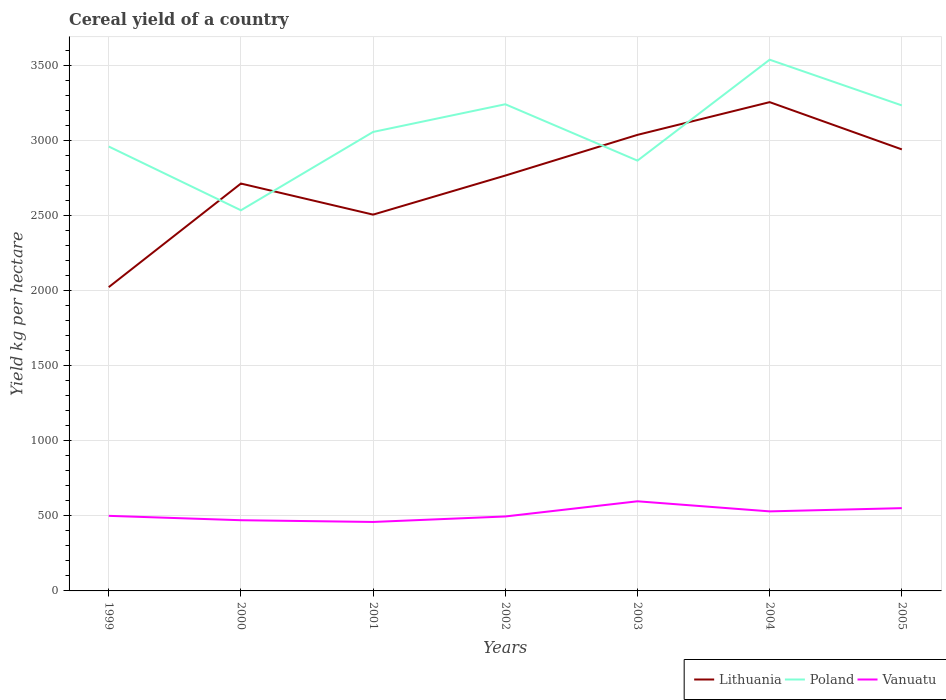How many different coloured lines are there?
Give a very brief answer. 3. Is the number of lines equal to the number of legend labels?
Make the answer very short. Yes. Across all years, what is the maximum total cereal yield in Lithuania?
Keep it short and to the point. 2022.91. What is the total total cereal yield in Vanuatu in the graph?
Make the answer very short. -137.57. What is the difference between the highest and the second highest total cereal yield in Lithuania?
Your response must be concise. 1231.95. How many years are there in the graph?
Keep it short and to the point. 7. What is the difference between two consecutive major ticks on the Y-axis?
Make the answer very short. 500. Where does the legend appear in the graph?
Offer a terse response. Bottom right. How many legend labels are there?
Ensure brevity in your answer.  3. How are the legend labels stacked?
Ensure brevity in your answer.  Horizontal. What is the title of the graph?
Your response must be concise. Cereal yield of a country. What is the label or title of the X-axis?
Your answer should be very brief. Years. What is the label or title of the Y-axis?
Ensure brevity in your answer.  Yield kg per hectare. What is the Yield kg per hectare of Lithuania in 1999?
Provide a succinct answer. 2022.91. What is the Yield kg per hectare of Poland in 1999?
Your answer should be very brief. 2959.36. What is the Yield kg per hectare of Lithuania in 2000?
Ensure brevity in your answer.  2712.78. What is the Yield kg per hectare in Poland in 2000?
Ensure brevity in your answer.  2534.78. What is the Yield kg per hectare of Vanuatu in 2000?
Your answer should be very brief. 470.86. What is the Yield kg per hectare in Lithuania in 2001?
Ensure brevity in your answer.  2505.83. What is the Yield kg per hectare in Poland in 2001?
Your answer should be compact. 3056.4. What is the Yield kg per hectare of Vanuatu in 2001?
Your response must be concise. 459.29. What is the Yield kg per hectare in Lithuania in 2002?
Your response must be concise. 2765.9. What is the Yield kg per hectare of Poland in 2002?
Ensure brevity in your answer.  3240.8. What is the Yield kg per hectare in Vanuatu in 2002?
Provide a succinct answer. 495.79. What is the Yield kg per hectare in Lithuania in 2003?
Offer a terse response. 3037.01. What is the Yield kg per hectare in Poland in 2003?
Offer a very short reply. 2865.37. What is the Yield kg per hectare of Vanuatu in 2003?
Offer a very short reply. 596.86. What is the Yield kg per hectare in Lithuania in 2004?
Your answer should be compact. 3254.87. What is the Yield kg per hectare of Poland in 2004?
Offer a very short reply. 3537.57. What is the Yield kg per hectare of Vanuatu in 2004?
Your response must be concise. 529.69. What is the Yield kg per hectare in Lithuania in 2005?
Your answer should be compact. 2940.17. What is the Yield kg per hectare in Poland in 2005?
Your answer should be compact. 3233.07. What is the Yield kg per hectare in Vanuatu in 2005?
Your response must be concise. 551.28. Across all years, what is the maximum Yield kg per hectare of Lithuania?
Provide a short and direct response. 3254.87. Across all years, what is the maximum Yield kg per hectare of Poland?
Provide a succinct answer. 3537.57. Across all years, what is the maximum Yield kg per hectare in Vanuatu?
Provide a short and direct response. 596.86. Across all years, what is the minimum Yield kg per hectare of Lithuania?
Make the answer very short. 2022.91. Across all years, what is the minimum Yield kg per hectare of Poland?
Your answer should be compact. 2534.78. Across all years, what is the minimum Yield kg per hectare in Vanuatu?
Your answer should be very brief. 459.29. What is the total Yield kg per hectare of Lithuania in the graph?
Give a very brief answer. 1.92e+04. What is the total Yield kg per hectare in Poland in the graph?
Offer a very short reply. 2.14e+04. What is the total Yield kg per hectare of Vanuatu in the graph?
Offer a terse response. 3603.78. What is the difference between the Yield kg per hectare of Lithuania in 1999 and that in 2000?
Your answer should be compact. -689.87. What is the difference between the Yield kg per hectare in Poland in 1999 and that in 2000?
Give a very brief answer. 424.58. What is the difference between the Yield kg per hectare of Vanuatu in 1999 and that in 2000?
Keep it short and to the point. 29.14. What is the difference between the Yield kg per hectare in Lithuania in 1999 and that in 2001?
Your answer should be very brief. -482.92. What is the difference between the Yield kg per hectare of Poland in 1999 and that in 2001?
Give a very brief answer. -97.04. What is the difference between the Yield kg per hectare in Vanuatu in 1999 and that in 2001?
Provide a short and direct response. 40.71. What is the difference between the Yield kg per hectare of Lithuania in 1999 and that in 2002?
Ensure brevity in your answer.  -742.99. What is the difference between the Yield kg per hectare of Poland in 1999 and that in 2002?
Keep it short and to the point. -281.44. What is the difference between the Yield kg per hectare in Vanuatu in 1999 and that in 2002?
Provide a succinct answer. 4.21. What is the difference between the Yield kg per hectare in Lithuania in 1999 and that in 2003?
Your response must be concise. -1014.1. What is the difference between the Yield kg per hectare of Poland in 1999 and that in 2003?
Offer a very short reply. 93.99. What is the difference between the Yield kg per hectare of Vanuatu in 1999 and that in 2003?
Your answer should be very brief. -96.86. What is the difference between the Yield kg per hectare in Lithuania in 1999 and that in 2004?
Provide a succinct answer. -1231.95. What is the difference between the Yield kg per hectare of Poland in 1999 and that in 2004?
Offer a very short reply. -578.2. What is the difference between the Yield kg per hectare in Vanuatu in 1999 and that in 2004?
Provide a short and direct response. -29.69. What is the difference between the Yield kg per hectare of Lithuania in 1999 and that in 2005?
Offer a terse response. -917.26. What is the difference between the Yield kg per hectare of Poland in 1999 and that in 2005?
Keep it short and to the point. -273.71. What is the difference between the Yield kg per hectare of Vanuatu in 1999 and that in 2005?
Your answer should be compact. -51.28. What is the difference between the Yield kg per hectare in Lithuania in 2000 and that in 2001?
Your answer should be compact. 206.96. What is the difference between the Yield kg per hectare of Poland in 2000 and that in 2001?
Make the answer very short. -521.62. What is the difference between the Yield kg per hectare in Vanuatu in 2000 and that in 2001?
Your response must be concise. 11.57. What is the difference between the Yield kg per hectare in Lithuania in 2000 and that in 2002?
Give a very brief answer. -53.12. What is the difference between the Yield kg per hectare in Poland in 2000 and that in 2002?
Your answer should be compact. -706.02. What is the difference between the Yield kg per hectare in Vanuatu in 2000 and that in 2002?
Give a very brief answer. -24.93. What is the difference between the Yield kg per hectare of Lithuania in 2000 and that in 2003?
Keep it short and to the point. -324.23. What is the difference between the Yield kg per hectare in Poland in 2000 and that in 2003?
Offer a very short reply. -330.59. What is the difference between the Yield kg per hectare in Vanuatu in 2000 and that in 2003?
Keep it short and to the point. -126. What is the difference between the Yield kg per hectare in Lithuania in 2000 and that in 2004?
Make the answer very short. -542.08. What is the difference between the Yield kg per hectare of Poland in 2000 and that in 2004?
Provide a succinct answer. -1002.78. What is the difference between the Yield kg per hectare in Vanuatu in 2000 and that in 2004?
Your response must be concise. -58.84. What is the difference between the Yield kg per hectare in Lithuania in 2000 and that in 2005?
Ensure brevity in your answer.  -227.39. What is the difference between the Yield kg per hectare of Poland in 2000 and that in 2005?
Keep it short and to the point. -698.29. What is the difference between the Yield kg per hectare in Vanuatu in 2000 and that in 2005?
Offer a very short reply. -80.42. What is the difference between the Yield kg per hectare in Lithuania in 2001 and that in 2002?
Keep it short and to the point. -260.08. What is the difference between the Yield kg per hectare of Poland in 2001 and that in 2002?
Provide a short and direct response. -184.4. What is the difference between the Yield kg per hectare of Vanuatu in 2001 and that in 2002?
Your answer should be compact. -36.5. What is the difference between the Yield kg per hectare in Lithuania in 2001 and that in 2003?
Your response must be concise. -531.18. What is the difference between the Yield kg per hectare of Poland in 2001 and that in 2003?
Your response must be concise. 191.03. What is the difference between the Yield kg per hectare of Vanuatu in 2001 and that in 2003?
Offer a terse response. -137.57. What is the difference between the Yield kg per hectare in Lithuania in 2001 and that in 2004?
Provide a short and direct response. -749.04. What is the difference between the Yield kg per hectare of Poland in 2001 and that in 2004?
Provide a short and direct response. -481.17. What is the difference between the Yield kg per hectare in Vanuatu in 2001 and that in 2004?
Ensure brevity in your answer.  -70.4. What is the difference between the Yield kg per hectare in Lithuania in 2001 and that in 2005?
Your response must be concise. -434.35. What is the difference between the Yield kg per hectare of Poland in 2001 and that in 2005?
Your answer should be very brief. -176.67. What is the difference between the Yield kg per hectare in Vanuatu in 2001 and that in 2005?
Offer a terse response. -91.99. What is the difference between the Yield kg per hectare in Lithuania in 2002 and that in 2003?
Ensure brevity in your answer.  -271.11. What is the difference between the Yield kg per hectare in Poland in 2002 and that in 2003?
Give a very brief answer. 375.43. What is the difference between the Yield kg per hectare of Vanuatu in 2002 and that in 2003?
Your response must be concise. -101.06. What is the difference between the Yield kg per hectare in Lithuania in 2002 and that in 2004?
Offer a terse response. -488.96. What is the difference between the Yield kg per hectare in Poland in 2002 and that in 2004?
Your answer should be very brief. -296.76. What is the difference between the Yield kg per hectare of Vanuatu in 2002 and that in 2004?
Offer a terse response. -33.9. What is the difference between the Yield kg per hectare in Lithuania in 2002 and that in 2005?
Offer a very short reply. -174.27. What is the difference between the Yield kg per hectare of Poland in 2002 and that in 2005?
Offer a very short reply. 7.73. What is the difference between the Yield kg per hectare of Vanuatu in 2002 and that in 2005?
Provide a short and direct response. -55.49. What is the difference between the Yield kg per hectare in Lithuania in 2003 and that in 2004?
Provide a short and direct response. -217.85. What is the difference between the Yield kg per hectare of Poland in 2003 and that in 2004?
Keep it short and to the point. -672.19. What is the difference between the Yield kg per hectare of Vanuatu in 2003 and that in 2004?
Your answer should be very brief. 67.17. What is the difference between the Yield kg per hectare of Lithuania in 2003 and that in 2005?
Ensure brevity in your answer.  96.84. What is the difference between the Yield kg per hectare of Poland in 2003 and that in 2005?
Ensure brevity in your answer.  -367.7. What is the difference between the Yield kg per hectare of Vanuatu in 2003 and that in 2005?
Your answer should be compact. 45.58. What is the difference between the Yield kg per hectare of Lithuania in 2004 and that in 2005?
Make the answer very short. 314.69. What is the difference between the Yield kg per hectare in Poland in 2004 and that in 2005?
Your answer should be compact. 304.5. What is the difference between the Yield kg per hectare of Vanuatu in 2004 and that in 2005?
Provide a short and direct response. -21.59. What is the difference between the Yield kg per hectare of Lithuania in 1999 and the Yield kg per hectare of Poland in 2000?
Offer a very short reply. -511.87. What is the difference between the Yield kg per hectare in Lithuania in 1999 and the Yield kg per hectare in Vanuatu in 2000?
Make the answer very short. 1552.05. What is the difference between the Yield kg per hectare in Poland in 1999 and the Yield kg per hectare in Vanuatu in 2000?
Ensure brevity in your answer.  2488.5. What is the difference between the Yield kg per hectare of Lithuania in 1999 and the Yield kg per hectare of Poland in 2001?
Your answer should be very brief. -1033.49. What is the difference between the Yield kg per hectare in Lithuania in 1999 and the Yield kg per hectare in Vanuatu in 2001?
Ensure brevity in your answer.  1563.62. What is the difference between the Yield kg per hectare of Poland in 1999 and the Yield kg per hectare of Vanuatu in 2001?
Offer a terse response. 2500.07. What is the difference between the Yield kg per hectare of Lithuania in 1999 and the Yield kg per hectare of Poland in 2002?
Offer a terse response. -1217.89. What is the difference between the Yield kg per hectare of Lithuania in 1999 and the Yield kg per hectare of Vanuatu in 2002?
Provide a succinct answer. 1527.12. What is the difference between the Yield kg per hectare of Poland in 1999 and the Yield kg per hectare of Vanuatu in 2002?
Your response must be concise. 2463.57. What is the difference between the Yield kg per hectare of Lithuania in 1999 and the Yield kg per hectare of Poland in 2003?
Make the answer very short. -842.46. What is the difference between the Yield kg per hectare of Lithuania in 1999 and the Yield kg per hectare of Vanuatu in 2003?
Your answer should be compact. 1426.05. What is the difference between the Yield kg per hectare of Poland in 1999 and the Yield kg per hectare of Vanuatu in 2003?
Provide a short and direct response. 2362.5. What is the difference between the Yield kg per hectare in Lithuania in 1999 and the Yield kg per hectare in Poland in 2004?
Provide a succinct answer. -1514.65. What is the difference between the Yield kg per hectare of Lithuania in 1999 and the Yield kg per hectare of Vanuatu in 2004?
Your answer should be compact. 1493.22. What is the difference between the Yield kg per hectare of Poland in 1999 and the Yield kg per hectare of Vanuatu in 2004?
Your answer should be compact. 2429.67. What is the difference between the Yield kg per hectare in Lithuania in 1999 and the Yield kg per hectare in Poland in 2005?
Offer a terse response. -1210.16. What is the difference between the Yield kg per hectare of Lithuania in 1999 and the Yield kg per hectare of Vanuatu in 2005?
Keep it short and to the point. 1471.63. What is the difference between the Yield kg per hectare of Poland in 1999 and the Yield kg per hectare of Vanuatu in 2005?
Provide a succinct answer. 2408.08. What is the difference between the Yield kg per hectare in Lithuania in 2000 and the Yield kg per hectare in Poland in 2001?
Your answer should be compact. -343.62. What is the difference between the Yield kg per hectare in Lithuania in 2000 and the Yield kg per hectare in Vanuatu in 2001?
Ensure brevity in your answer.  2253.49. What is the difference between the Yield kg per hectare of Poland in 2000 and the Yield kg per hectare of Vanuatu in 2001?
Your answer should be compact. 2075.49. What is the difference between the Yield kg per hectare in Lithuania in 2000 and the Yield kg per hectare in Poland in 2002?
Your answer should be compact. -528.02. What is the difference between the Yield kg per hectare of Lithuania in 2000 and the Yield kg per hectare of Vanuatu in 2002?
Offer a very short reply. 2216.99. What is the difference between the Yield kg per hectare of Poland in 2000 and the Yield kg per hectare of Vanuatu in 2002?
Offer a terse response. 2038.99. What is the difference between the Yield kg per hectare of Lithuania in 2000 and the Yield kg per hectare of Poland in 2003?
Provide a short and direct response. -152.59. What is the difference between the Yield kg per hectare of Lithuania in 2000 and the Yield kg per hectare of Vanuatu in 2003?
Make the answer very short. 2115.92. What is the difference between the Yield kg per hectare of Poland in 2000 and the Yield kg per hectare of Vanuatu in 2003?
Make the answer very short. 1937.92. What is the difference between the Yield kg per hectare of Lithuania in 2000 and the Yield kg per hectare of Poland in 2004?
Your answer should be compact. -824.78. What is the difference between the Yield kg per hectare in Lithuania in 2000 and the Yield kg per hectare in Vanuatu in 2004?
Keep it short and to the point. 2183.09. What is the difference between the Yield kg per hectare in Poland in 2000 and the Yield kg per hectare in Vanuatu in 2004?
Your response must be concise. 2005.09. What is the difference between the Yield kg per hectare of Lithuania in 2000 and the Yield kg per hectare of Poland in 2005?
Your response must be concise. -520.29. What is the difference between the Yield kg per hectare of Lithuania in 2000 and the Yield kg per hectare of Vanuatu in 2005?
Provide a succinct answer. 2161.5. What is the difference between the Yield kg per hectare in Poland in 2000 and the Yield kg per hectare in Vanuatu in 2005?
Provide a succinct answer. 1983.5. What is the difference between the Yield kg per hectare in Lithuania in 2001 and the Yield kg per hectare in Poland in 2002?
Offer a terse response. -734.98. What is the difference between the Yield kg per hectare of Lithuania in 2001 and the Yield kg per hectare of Vanuatu in 2002?
Give a very brief answer. 2010.03. What is the difference between the Yield kg per hectare of Poland in 2001 and the Yield kg per hectare of Vanuatu in 2002?
Keep it short and to the point. 2560.61. What is the difference between the Yield kg per hectare of Lithuania in 2001 and the Yield kg per hectare of Poland in 2003?
Offer a very short reply. -359.55. What is the difference between the Yield kg per hectare in Lithuania in 2001 and the Yield kg per hectare in Vanuatu in 2003?
Offer a very short reply. 1908.97. What is the difference between the Yield kg per hectare in Poland in 2001 and the Yield kg per hectare in Vanuatu in 2003?
Offer a terse response. 2459.54. What is the difference between the Yield kg per hectare of Lithuania in 2001 and the Yield kg per hectare of Poland in 2004?
Your response must be concise. -1031.74. What is the difference between the Yield kg per hectare of Lithuania in 2001 and the Yield kg per hectare of Vanuatu in 2004?
Offer a terse response. 1976.13. What is the difference between the Yield kg per hectare of Poland in 2001 and the Yield kg per hectare of Vanuatu in 2004?
Give a very brief answer. 2526.7. What is the difference between the Yield kg per hectare in Lithuania in 2001 and the Yield kg per hectare in Poland in 2005?
Your answer should be compact. -727.24. What is the difference between the Yield kg per hectare of Lithuania in 2001 and the Yield kg per hectare of Vanuatu in 2005?
Your answer should be very brief. 1954.54. What is the difference between the Yield kg per hectare in Poland in 2001 and the Yield kg per hectare in Vanuatu in 2005?
Ensure brevity in your answer.  2505.12. What is the difference between the Yield kg per hectare of Lithuania in 2002 and the Yield kg per hectare of Poland in 2003?
Make the answer very short. -99.47. What is the difference between the Yield kg per hectare of Lithuania in 2002 and the Yield kg per hectare of Vanuatu in 2003?
Keep it short and to the point. 2169.05. What is the difference between the Yield kg per hectare in Poland in 2002 and the Yield kg per hectare in Vanuatu in 2003?
Provide a short and direct response. 2643.94. What is the difference between the Yield kg per hectare of Lithuania in 2002 and the Yield kg per hectare of Poland in 2004?
Your answer should be very brief. -771.66. What is the difference between the Yield kg per hectare in Lithuania in 2002 and the Yield kg per hectare in Vanuatu in 2004?
Make the answer very short. 2236.21. What is the difference between the Yield kg per hectare of Poland in 2002 and the Yield kg per hectare of Vanuatu in 2004?
Keep it short and to the point. 2711.11. What is the difference between the Yield kg per hectare of Lithuania in 2002 and the Yield kg per hectare of Poland in 2005?
Provide a succinct answer. -467.17. What is the difference between the Yield kg per hectare of Lithuania in 2002 and the Yield kg per hectare of Vanuatu in 2005?
Your answer should be compact. 2214.62. What is the difference between the Yield kg per hectare of Poland in 2002 and the Yield kg per hectare of Vanuatu in 2005?
Your answer should be compact. 2689.52. What is the difference between the Yield kg per hectare in Lithuania in 2003 and the Yield kg per hectare in Poland in 2004?
Give a very brief answer. -500.55. What is the difference between the Yield kg per hectare in Lithuania in 2003 and the Yield kg per hectare in Vanuatu in 2004?
Keep it short and to the point. 2507.32. What is the difference between the Yield kg per hectare of Poland in 2003 and the Yield kg per hectare of Vanuatu in 2004?
Offer a very short reply. 2335.68. What is the difference between the Yield kg per hectare of Lithuania in 2003 and the Yield kg per hectare of Poland in 2005?
Make the answer very short. -196.06. What is the difference between the Yield kg per hectare in Lithuania in 2003 and the Yield kg per hectare in Vanuatu in 2005?
Offer a very short reply. 2485.73. What is the difference between the Yield kg per hectare in Poland in 2003 and the Yield kg per hectare in Vanuatu in 2005?
Your answer should be very brief. 2314.09. What is the difference between the Yield kg per hectare in Lithuania in 2004 and the Yield kg per hectare in Poland in 2005?
Keep it short and to the point. 21.8. What is the difference between the Yield kg per hectare in Lithuania in 2004 and the Yield kg per hectare in Vanuatu in 2005?
Provide a short and direct response. 2703.58. What is the difference between the Yield kg per hectare of Poland in 2004 and the Yield kg per hectare of Vanuatu in 2005?
Your response must be concise. 2986.28. What is the average Yield kg per hectare of Lithuania per year?
Provide a short and direct response. 2748.5. What is the average Yield kg per hectare of Poland per year?
Ensure brevity in your answer.  3061.05. What is the average Yield kg per hectare in Vanuatu per year?
Offer a terse response. 514.83. In the year 1999, what is the difference between the Yield kg per hectare in Lithuania and Yield kg per hectare in Poland?
Provide a short and direct response. -936.45. In the year 1999, what is the difference between the Yield kg per hectare in Lithuania and Yield kg per hectare in Vanuatu?
Provide a short and direct response. 1522.91. In the year 1999, what is the difference between the Yield kg per hectare of Poland and Yield kg per hectare of Vanuatu?
Offer a very short reply. 2459.36. In the year 2000, what is the difference between the Yield kg per hectare in Lithuania and Yield kg per hectare in Poland?
Offer a very short reply. 178. In the year 2000, what is the difference between the Yield kg per hectare of Lithuania and Yield kg per hectare of Vanuatu?
Offer a very short reply. 2241.92. In the year 2000, what is the difference between the Yield kg per hectare in Poland and Yield kg per hectare in Vanuatu?
Offer a terse response. 2063.92. In the year 2001, what is the difference between the Yield kg per hectare of Lithuania and Yield kg per hectare of Poland?
Provide a short and direct response. -550.57. In the year 2001, what is the difference between the Yield kg per hectare of Lithuania and Yield kg per hectare of Vanuatu?
Keep it short and to the point. 2046.53. In the year 2001, what is the difference between the Yield kg per hectare of Poland and Yield kg per hectare of Vanuatu?
Give a very brief answer. 2597.11. In the year 2002, what is the difference between the Yield kg per hectare of Lithuania and Yield kg per hectare of Poland?
Your answer should be compact. -474.9. In the year 2002, what is the difference between the Yield kg per hectare of Lithuania and Yield kg per hectare of Vanuatu?
Provide a short and direct response. 2270.11. In the year 2002, what is the difference between the Yield kg per hectare in Poland and Yield kg per hectare in Vanuatu?
Your response must be concise. 2745.01. In the year 2003, what is the difference between the Yield kg per hectare of Lithuania and Yield kg per hectare of Poland?
Ensure brevity in your answer.  171.64. In the year 2003, what is the difference between the Yield kg per hectare in Lithuania and Yield kg per hectare in Vanuatu?
Make the answer very short. 2440.15. In the year 2003, what is the difference between the Yield kg per hectare in Poland and Yield kg per hectare in Vanuatu?
Your response must be concise. 2268.51. In the year 2004, what is the difference between the Yield kg per hectare in Lithuania and Yield kg per hectare in Poland?
Your answer should be very brief. -282.7. In the year 2004, what is the difference between the Yield kg per hectare of Lithuania and Yield kg per hectare of Vanuatu?
Keep it short and to the point. 2725.17. In the year 2004, what is the difference between the Yield kg per hectare in Poland and Yield kg per hectare in Vanuatu?
Provide a succinct answer. 3007.87. In the year 2005, what is the difference between the Yield kg per hectare in Lithuania and Yield kg per hectare in Poland?
Give a very brief answer. -292.89. In the year 2005, what is the difference between the Yield kg per hectare of Lithuania and Yield kg per hectare of Vanuatu?
Your response must be concise. 2388.89. In the year 2005, what is the difference between the Yield kg per hectare in Poland and Yield kg per hectare in Vanuatu?
Your response must be concise. 2681.79. What is the ratio of the Yield kg per hectare in Lithuania in 1999 to that in 2000?
Ensure brevity in your answer.  0.75. What is the ratio of the Yield kg per hectare in Poland in 1999 to that in 2000?
Make the answer very short. 1.17. What is the ratio of the Yield kg per hectare in Vanuatu in 1999 to that in 2000?
Ensure brevity in your answer.  1.06. What is the ratio of the Yield kg per hectare in Lithuania in 1999 to that in 2001?
Provide a succinct answer. 0.81. What is the ratio of the Yield kg per hectare in Poland in 1999 to that in 2001?
Keep it short and to the point. 0.97. What is the ratio of the Yield kg per hectare of Vanuatu in 1999 to that in 2001?
Your answer should be very brief. 1.09. What is the ratio of the Yield kg per hectare in Lithuania in 1999 to that in 2002?
Ensure brevity in your answer.  0.73. What is the ratio of the Yield kg per hectare in Poland in 1999 to that in 2002?
Make the answer very short. 0.91. What is the ratio of the Yield kg per hectare in Vanuatu in 1999 to that in 2002?
Make the answer very short. 1.01. What is the ratio of the Yield kg per hectare in Lithuania in 1999 to that in 2003?
Offer a terse response. 0.67. What is the ratio of the Yield kg per hectare in Poland in 1999 to that in 2003?
Provide a short and direct response. 1.03. What is the ratio of the Yield kg per hectare of Vanuatu in 1999 to that in 2003?
Provide a short and direct response. 0.84. What is the ratio of the Yield kg per hectare in Lithuania in 1999 to that in 2004?
Ensure brevity in your answer.  0.62. What is the ratio of the Yield kg per hectare of Poland in 1999 to that in 2004?
Offer a terse response. 0.84. What is the ratio of the Yield kg per hectare in Vanuatu in 1999 to that in 2004?
Keep it short and to the point. 0.94. What is the ratio of the Yield kg per hectare in Lithuania in 1999 to that in 2005?
Offer a very short reply. 0.69. What is the ratio of the Yield kg per hectare of Poland in 1999 to that in 2005?
Your answer should be compact. 0.92. What is the ratio of the Yield kg per hectare of Vanuatu in 1999 to that in 2005?
Make the answer very short. 0.91. What is the ratio of the Yield kg per hectare of Lithuania in 2000 to that in 2001?
Offer a very short reply. 1.08. What is the ratio of the Yield kg per hectare of Poland in 2000 to that in 2001?
Your answer should be compact. 0.83. What is the ratio of the Yield kg per hectare of Vanuatu in 2000 to that in 2001?
Keep it short and to the point. 1.03. What is the ratio of the Yield kg per hectare in Lithuania in 2000 to that in 2002?
Provide a short and direct response. 0.98. What is the ratio of the Yield kg per hectare of Poland in 2000 to that in 2002?
Your response must be concise. 0.78. What is the ratio of the Yield kg per hectare in Vanuatu in 2000 to that in 2002?
Offer a terse response. 0.95. What is the ratio of the Yield kg per hectare in Lithuania in 2000 to that in 2003?
Your response must be concise. 0.89. What is the ratio of the Yield kg per hectare of Poland in 2000 to that in 2003?
Your answer should be very brief. 0.88. What is the ratio of the Yield kg per hectare of Vanuatu in 2000 to that in 2003?
Your answer should be compact. 0.79. What is the ratio of the Yield kg per hectare of Lithuania in 2000 to that in 2004?
Keep it short and to the point. 0.83. What is the ratio of the Yield kg per hectare in Poland in 2000 to that in 2004?
Make the answer very short. 0.72. What is the ratio of the Yield kg per hectare of Lithuania in 2000 to that in 2005?
Give a very brief answer. 0.92. What is the ratio of the Yield kg per hectare in Poland in 2000 to that in 2005?
Keep it short and to the point. 0.78. What is the ratio of the Yield kg per hectare of Vanuatu in 2000 to that in 2005?
Offer a very short reply. 0.85. What is the ratio of the Yield kg per hectare in Lithuania in 2001 to that in 2002?
Keep it short and to the point. 0.91. What is the ratio of the Yield kg per hectare in Poland in 2001 to that in 2002?
Your answer should be compact. 0.94. What is the ratio of the Yield kg per hectare in Vanuatu in 2001 to that in 2002?
Provide a short and direct response. 0.93. What is the ratio of the Yield kg per hectare in Lithuania in 2001 to that in 2003?
Provide a short and direct response. 0.83. What is the ratio of the Yield kg per hectare of Poland in 2001 to that in 2003?
Your answer should be compact. 1.07. What is the ratio of the Yield kg per hectare of Vanuatu in 2001 to that in 2003?
Make the answer very short. 0.77. What is the ratio of the Yield kg per hectare of Lithuania in 2001 to that in 2004?
Ensure brevity in your answer.  0.77. What is the ratio of the Yield kg per hectare in Poland in 2001 to that in 2004?
Make the answer very short. 0.86. What is the ratio of the Yield kg per hectare in Vanuatu in 2001 to that in 2004?
Give a very brief answer. 0.87. What is the ratio of the Yield kg per hectare of Lithuania in 2001 to that in 2005?
Your answer should be very brief. 0.85. What is the ratio of the Yield kg per hectare of Poland in 2001 to that in 2005?
Your answer should be very brief. 0.95. What is the ratio of the Yield kg per hectare of Vanuatu in 2001 to that in 2005?
Your answer should be very brief. 0.83. What is the ratio of the Yield kg per hectare in Lithuania in 2002 to that in 2003?
Your response must be concise. 0.91. What is the ratio of the Yield kg per hectare in Poland in 2002 to that in 2003?
Give a very brief answer. 1.13. What is the ratio of the Yield kg per hectare in Vanuatu in 2002 to that in 2003?
Provide a succinct answer. 0.83. What is the ratio of the Yield kg per hectare of Lithuania in 2002 to that in 2004?
Give a very brief answer. 0.85. What is the ratio of the Yield kg per hectare of Poland in 2002 to that in 2004?
Ensure brevity in your answer.  0.92. What is the ratio of the Yield kg per hectare in Vanuatu in 2002 to that in 2004?
Provide a succinct answer. 0.94. What is the ratio of the Yield kg per hectare in Lithuania in 2002 to that in 2005?
Give a very brief answer. 0.94. What is the ratio of the Yield kg per hectare of Poland in 2002 to that in 2005?
Provide a succinct answer. 1. What is the ratio of the Yield kg per hectare of Vanuatu in 2002 to that in 2005?
Provide a short and direct response. 0.9. What is the ratio of the Yield kg per hectare in Lithuania in 2003 to that in 2004?
Keep it short and to the point. 0.93. What is the ratio of the Yield kg per hectare of Poland in 2003 to that in 2004?
Give a very brief answer. 0.81. What is the ratio of the Yield kg per hectare in Vanuatu in 2003 to that in 2004?
Your answer should be compact. 1.13. What is the ratio of the Yield kg per hectare in Lithuania in 2003 to that in 2005?
Keep it short and to the point. 1.03. What is the ratio of the Yield kg per hectare in Poland in 2003 to that in 2005?
Offer a terse response. 0.89. What is the ratio of the Yield kg per hectare in Vanuatu in 2003 to that in 2005?
Keep it short and to the point. 1.08. What is the ratio of the Yield kg per hectare in Lithuania in 2004 to that in 2005?
Offer a terse response. 1.11. What is the ratio of the Yield kg per hectare in Poland in 2004 to that in 2005?
Offer a very short reply. 1.09. What is the ratio of the Yield kg per hectare in Vanuatu in 2004 to that in 2005?
Your response must be concise. 0.96. What is the difference between the highest and the second highest Yield kg per hectare in Lithuania?
Your answer should be compact. 217.85. What is the difference between the highest and the second highest Yield kg per hectare in Poland?
Make the answer very short. 296.76. What is the difference between the highest and the second highest Yield kg per hectare in Vanuatu?
Your response must be concise. 45.58. What is the difference between the highest and the lowest Yield kg per hectare in Lithuania?
Your response must be concise. 1231.95. What is the difference between the highest and the lowest Yield kg per hectare in Poland?
Offer a terse response. 1002.78. What is the difference between the highest and the lowest Yield kg per hectare of Vanuatu?
Ensure brevity in your answer.  137.57. 